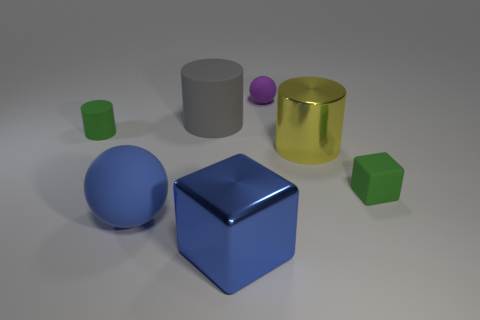The sphere on the left side of the big block is what color? blue 